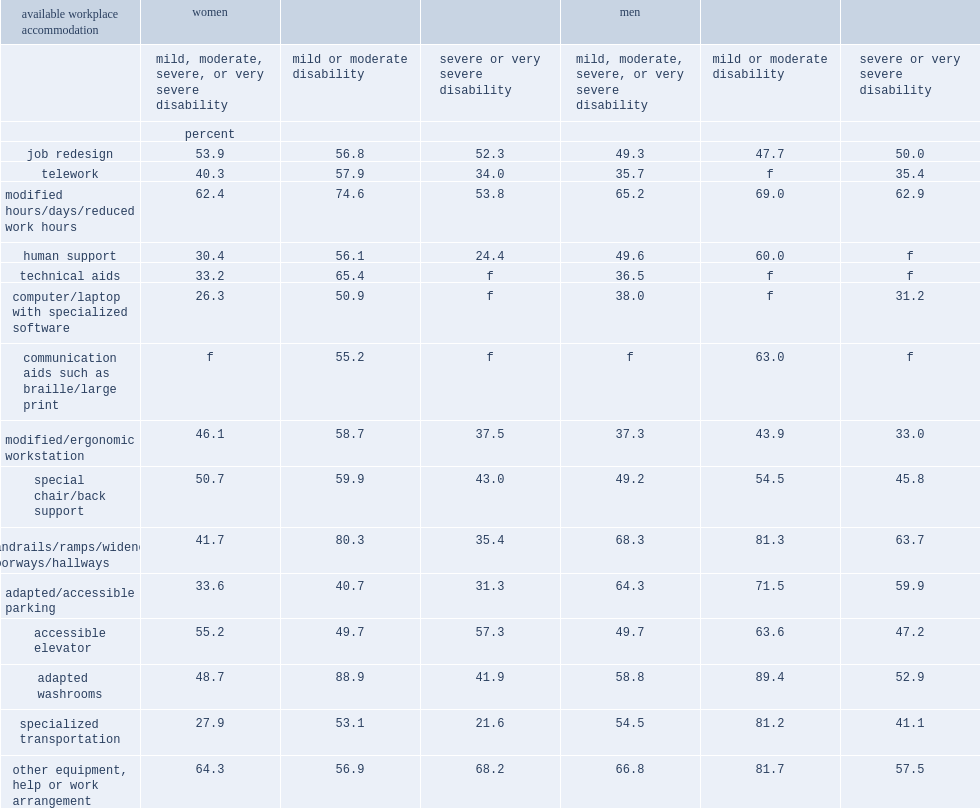Among people with disabilities who needed handrails, ramps, widened doorways or hallways as a work accommodation, who were more likly to had reported having this accommodation,men with disabilities or women with disabilities? Women. Who were more likly to had access to adapted or accessible parking and to specialized transportation,men with disabilities or women with disabilities? Women. What was the percentage of women with disabilities had access to adapted or accessible parking? 33.6. What was the percentage of men with disabilities had access to adapted or accessible parking? 64.3. What was the percentage of women with disabilities had access to specialized transit? 27.9. What was the percentage of men with disabilities had access to specialized transit? 54.5. 